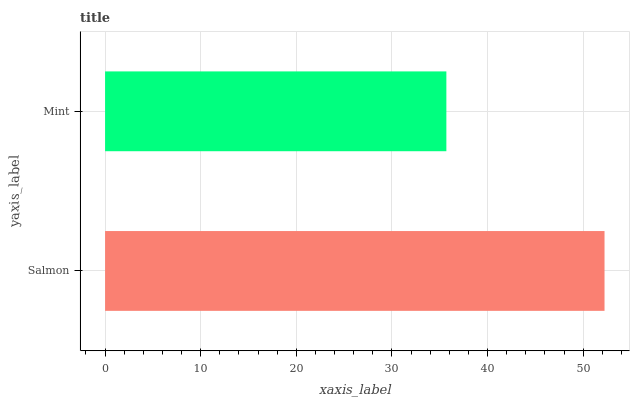Is Mint the minimum?
Answer yes or no. Yes. Is Salmon the maximum?
Answer yes or no. Yes. Is Mint the maximum?
Answer yes or no. No. Is Salmon greater than Mint?
Answer yes or no. Yes. Is Mint less than Salmon?
Answer yes or no. Yes. Is Mint greater than Salmon?
Answer yes or no. No. Is Salmon less than Mint?
Answer yes or no. No. Is Salmon the high median?
Answer yes or no. Yes. Is Mint the low median?
Answer yes or no. Yes. Is Mint the high median?
Answer yes or no. No. Is Salmon the low median?
Answer yes or no. No. 